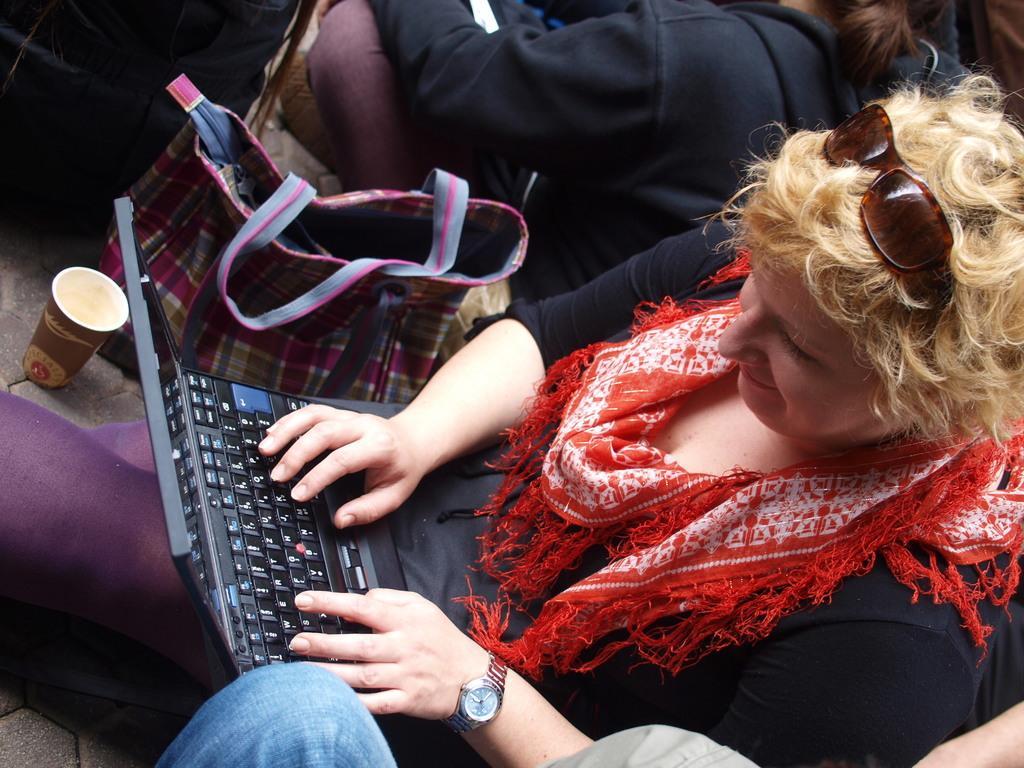Describe this image in one or two sentences. In this picture there are people, laptop, handbag, cup and other objects. 